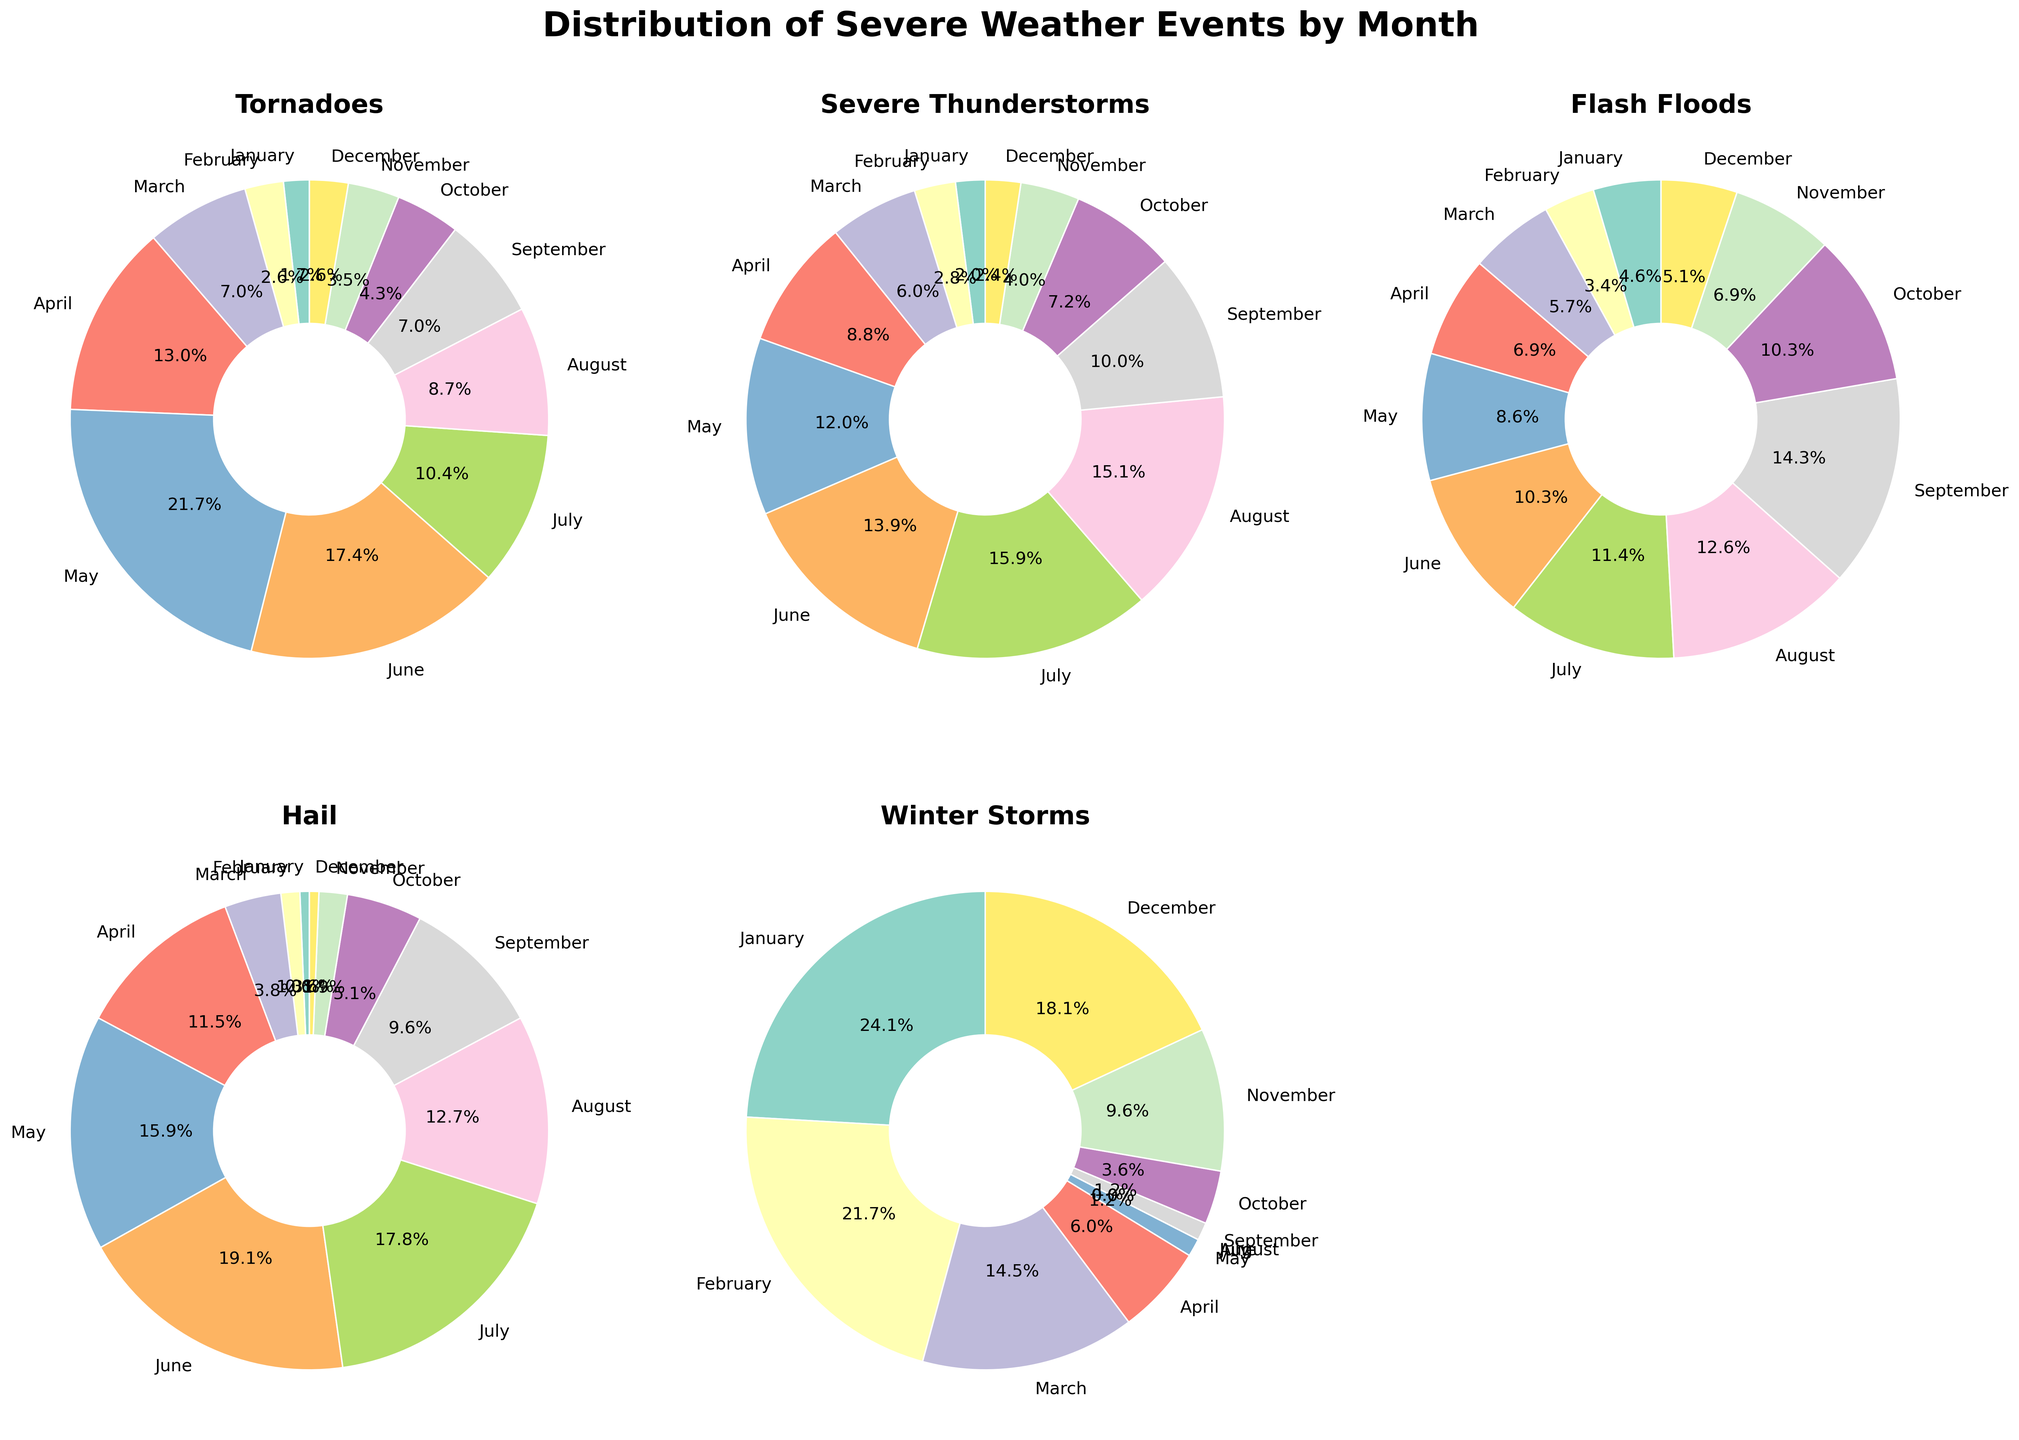What month has the highest percentage of severe thunderstorms? By examining the pie chart for Severe Thunderstorms, July has the largest slice of the pie.
Answer: July Which weather event is most common in December? The pie charts show that Winter Storms in December have the largest slice among the events.
Answer: Winter Storms How does the proportion of Tornadoes in May compare to Tornadoes in April? The pie chart for Tornadoes shows that May has a larger slice than April.
Answer: May has a higher proportion In which month do Flash Floods have the lowest percentage? By looking at the pie chart for Flash Floods, January has the smallest slice.
Answer: January What percentage of total severe weather events in August are Flash Floods? The pie chart for Flash Floods shows approximately 10.4% for August.
Answer: 10.4% Which month has a higher percentage of Hail events, March or September? The pie chart for Hail shows that March has a larger slice than September.
Answer: March Compare the slices of July and June for Severe Thunderstorms. Which is larger? The chart for Severe Thunderstorms shows July's slice is larger than June's slice.
Answer: July's slice is larger What is the proportion of Tornadoes in March? Observing the pie chart for Tornadoes, March has a slice of approximately 12.5%.
Answer: 12.5% How does the percentage of Winter Storms in January compare to February? The pie chart for Winter Storms shows that January's slice is slightly larger than February's slice.
Answer: January's slice is larger Which weather event in November has a greater proportion, Severe Thunderstorms or Flash Floods? By examining the respective pie charts, Severe Thunderstorms has a greater proportion in November than Flash Floods.
Answer: Severe Thunderstorms 